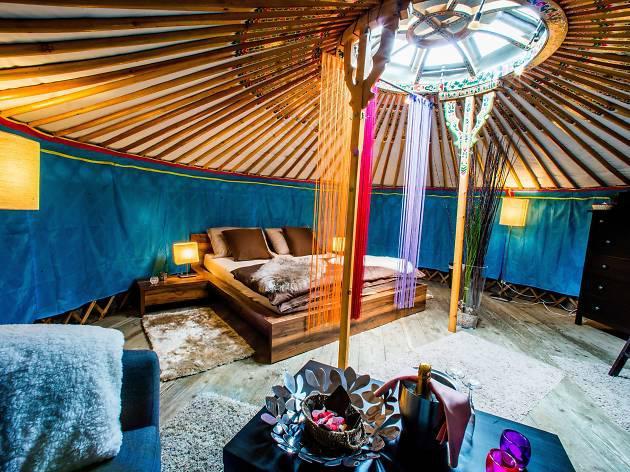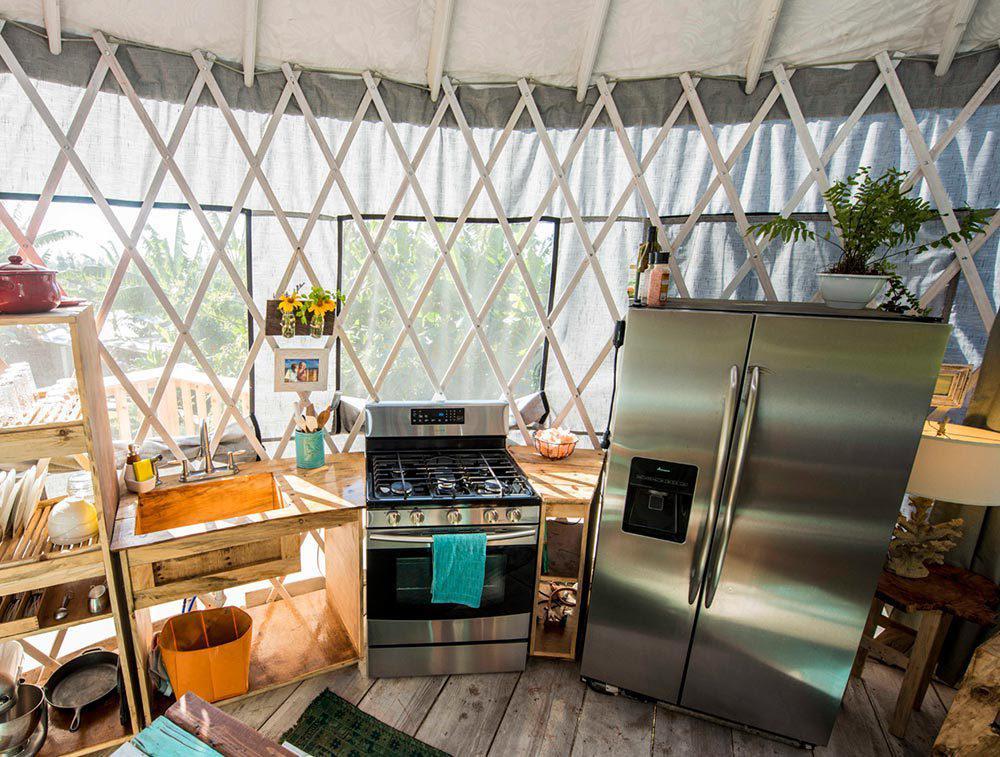The first image is the image on the left, the second image is the image on the right. For the images displayed, is the sentence "In one image, a stainless steel refrigerator is in the kitchen area of a yurt, while a second image shows a bedroom area." factually correct? Answer yes or no. Yes. The first image is the image on the left, the second image is the image on the right. Examine the images to the left and right. Is the description "The refridgerator is set up near the wall of a tent." accurate? Answer yes or no. Yes. 